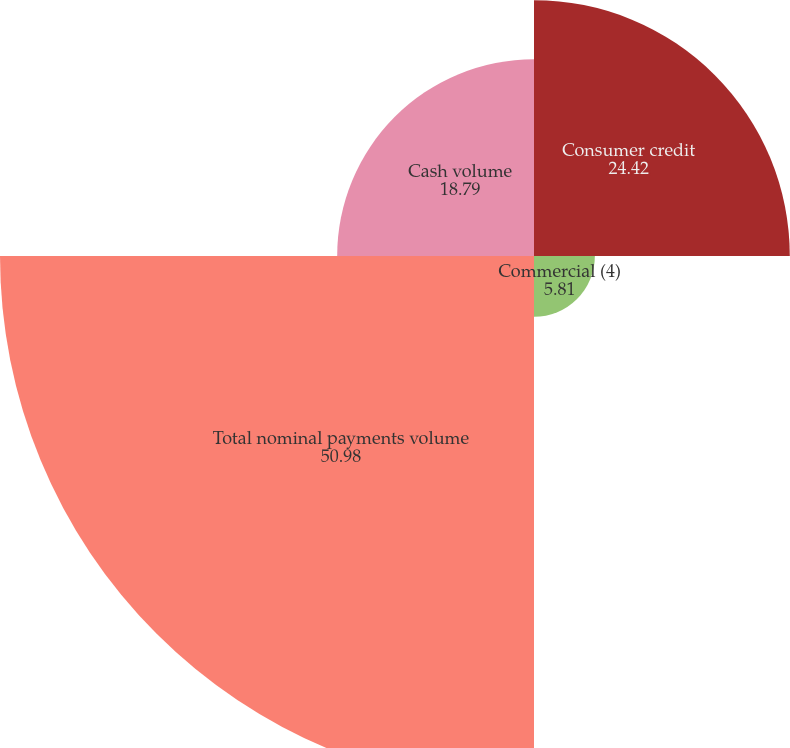Convert chart to OTSL. <chart><loc_0><loc_0><loc_500><loc_500><pie_chart><fcel>Consumer credit<fcel>Commercial (4)<fcel>Total nominal payments volume<fcel>Cash volume<nl><fcel>24.42%<fcel>5.81%<fcel>50.98%<fcel>18.79%<nl></chart> 